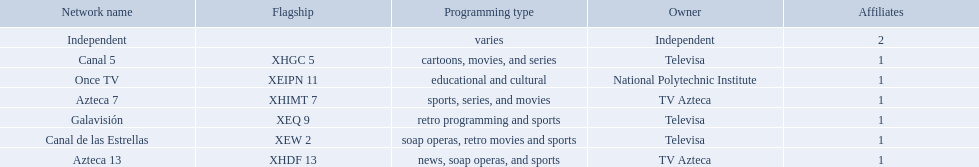What stations show sports? Soap operas, retro movies and sports, retro programming and sports, news, soap operas, and sports. Help me parse the entirety of this table. {'header': ['Network name', 'Flagship', 'Programming type', 'Owner', 'Affiliates'], 'rows': [['Independent', '', 'varies', 'Independent', '2'], ['Canal 5', 'XHGC 5', 'cartoons, movies, and series', 'Televisa', '1'], ['Once TV', 'XEIPN 11', 'educational and cultural', 'National Polytechnic Institute', '1'], ['Azteca 7', 'XHIMT 7', 'sports, series, and movies', 'TV Azteca', '1'], ['Galavisión', 'XEQ 9', 'retro programming and sports', 'Televisa', '1'], ['Canal de las Estrellas', 'XEW 2', 'soap operas, retro movies and sports', 'Televisa', '1'], ['Azteca 13', 'XHDF 13', 'news, soap operas, and sports', 'TV Azteca', '1']]} What of these is not affiliated with televisa? Azteca 7. 